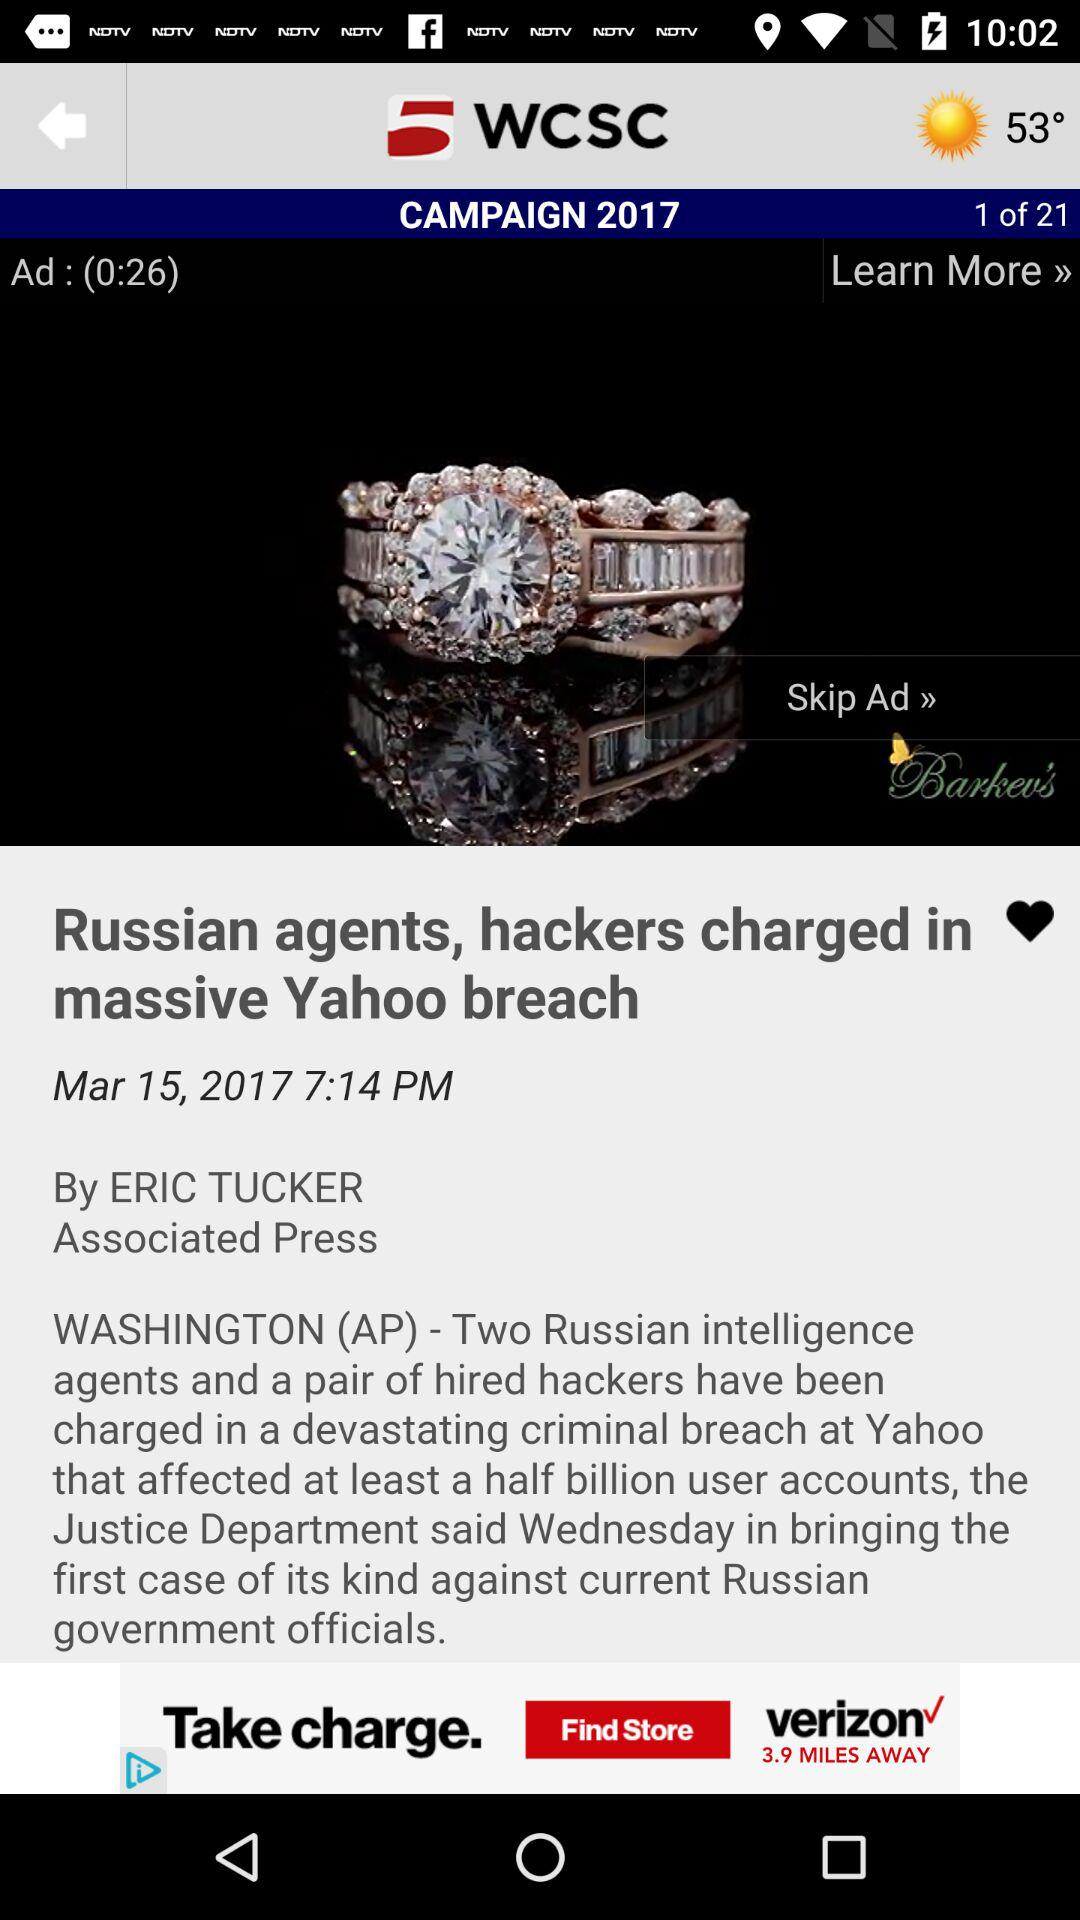What is the temperature? The temperature is 53°. 